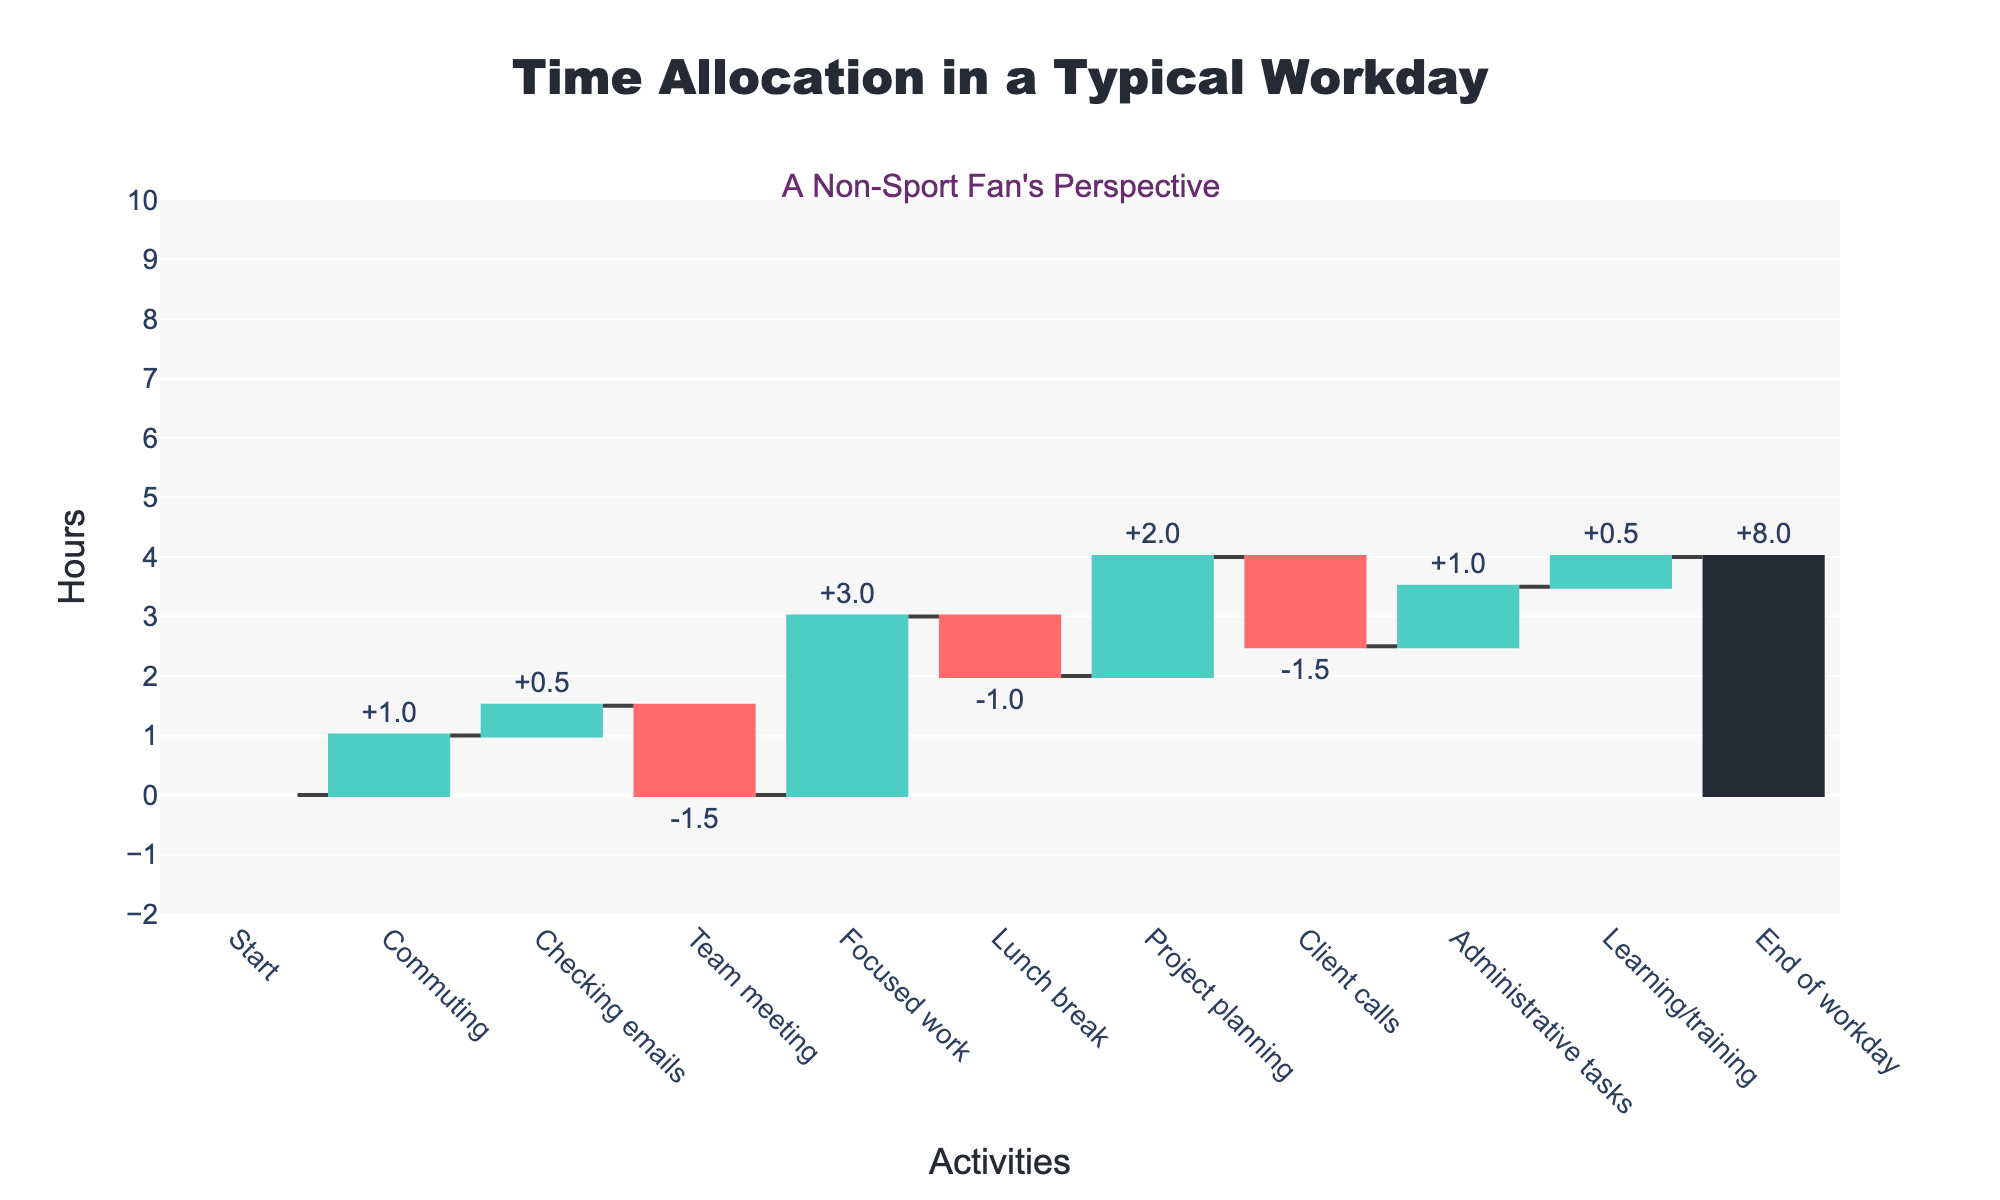What's the title of the chart? The title is usually displayed at the top of the chart. Here, it reads "Time Allocation in a Typical Workday".
Answer: Time Allocation in a Typical Workday Which activities show a negative time allocation (decrease) on the chart? Negative time allocation means that the bar points downwards. By examining the chart, these activities are "Team meeting," "Lunch break," and "Client calls".
Answer: Team meeting, Lunch break, Client calls How many hours are spent on "Checking emails" and "Administrative tasks" combined? To find the combined time, add the hours from these activities. Checking emails: 0.5 hours, Administrative tasks: 1 hour. So, 0.5 + 1 = 1.5 hours.
Answer: 1.5 hours What is the net increase in hours from "Start" to "End of workday"? In a waterfall chart, the net change from the first absolute bar to the final total bar represents the overall change. The net increase is from 0 hours to 8 hours, giving an 8-hour net increase.
Answer: 8 hours Which activity contributes the most to positive time allocation? The activity with the largest upwards bar contributes most positively. Here, "Focused work" at 3 hours is the highest positive allocation.
Answer: Focused work Compare the time spent on "Team meeting" and "Client calls". Which one takes more time, and by how much? Both activities have negative time allocations. "Team meeting" is -1.5 hours, "Client calls" is also -1.5 hours. Therefore, they take equal time.
Answer: They take equal time What is the total reduction in hours from all negative activities? Add up hours from all the activities that decrease the time: "Team meeting" (-1.5), "Lunch break" (-1), "Client calls" (-1.5). So, -1.5 + (-1) + (-1.5) = -4 hours.
Answer: -4 hours What is the average time spent on all activities with positive time allocation? Positive time allocation activities and their hours are: "Commuting" (1), "Checking emails" (0.5), "Focused work" (3), "Project planning" (2), "Administrative tasks" (1), "Learning/training" (0.5). Total time = 8 hours and number of activities = 6, so average = 8/6 = 1.33 hours.
Answer: 1.33 hours Is more time spent on "Lunch break" or "Checking emails"? "Lunch break" has a time allocation of -1 hour, while "Checking emails" has 0.5 hours. Considering absolute values, more time is spent on "Lunch break".
Answer: Lunch break What's the difference between maximum positive time allocation and maximum negative time allocation? The maximum positive time allocation is from "Focused work" (3 hours). The maximum negative time allocation is from "Team meeting" and "Client calls" (both -1.5 hours). Difference = 3 - 1.5 = 1.5 hours.
Answer: 1.5 hours 